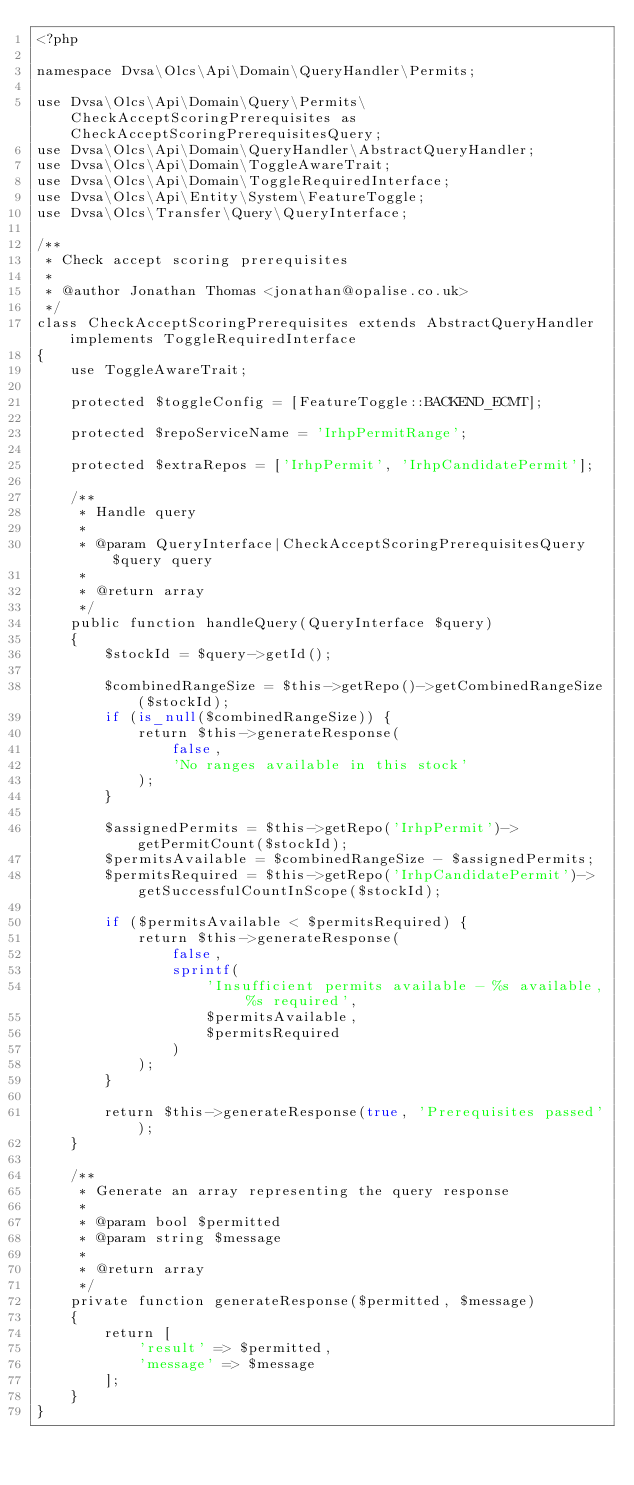<code> <loc_0><loc_0><loc_500><loc_500><_PHP_><?php

namespace Dvsa\Olcs\Api\Domain\QueryHandler\Permits;

use Dvsa\Olcs\Api\Domain\Query\Permits\CheckAcceptScoringPrerequisites as CheckAcceptScoringPrerequisitesQuery;
use Dvsa\Olcs\Api\Domain\QueryHandler\AbstractQueryHandler;
use Dvsa\Olcs\Api\Domain\ToggleAwareTrait;
use Dvsa\Olcs\Api\Domain\ToggleRequiredInterface;
use Dvsa\Olcs\Api\Entity\System\FeatureToggle;
use Dvsa\Olcs\Transfer\Query\QueryInterface;

/**
 * Check accept scoring prerequisites
 *
 * @author Jonathan Thomas <jonathan@opalise.co.uk>
 */
class CheckAcceptScoringPrerequisites extends AbstractQueryHandler implements ToggleRequiredInterface
{
    use ToggleAwareTrait;

    protected $toggleConfig = [FeatureToggle::BACKEND_ECMT];

    protected $repoServiceName = 'IrhpPermitRange';

    protected $extraRepos = ['IrhpPermit', 'IrhpCandidatePermit'];

    /**
     * Handle query
     *
     * @param QueryInterface|CheckAcceptScoringPrerequisitesQuery $query query
     *
     * @return array
     */
    public function handleQuery(QueryInterface $query)
    {
        $stockId = $query->getId();

        $combinedRangeSize = $this->getRepo()->getCombinedRangeSize($stockId);
        if (is_null($combinedRangeSize)) {
            return $this->generateResponse(
                false,
                'No ranges available in this stock'
            );
        }

        $assignedPermits = $this->getRepo('IrhpPermit')->getPermitCount($stockId);
        $permitsAvailable = $combinedRangeSize - $assignedPermits;
        $permitsRequired = $this->getRepo('IrhpCandidatePermit')->getSuccessfulCountInScope($stockId);

        if ($permitsAvailable < $permitsRequired) {
            return $this->generateResponse(
                false,
                sprintf(
                    'Insufficient permits available - %s available, %s required',
                    $permitsAvailable,
                    $permitsRequired
                )
            );
        }

        return $this->generateResponse(true, 'Prerequisites passed');
    }

    /**
     * Generate an array representing the query response
     *
     * @param bool $permitted
     * @param string $message
     *
     * @return array
     */
    private function generateResponse($permitted, $message)
    {
        return [
            'result' => $permitted,
            'message' => $message
        ];
    }
}
</code> 